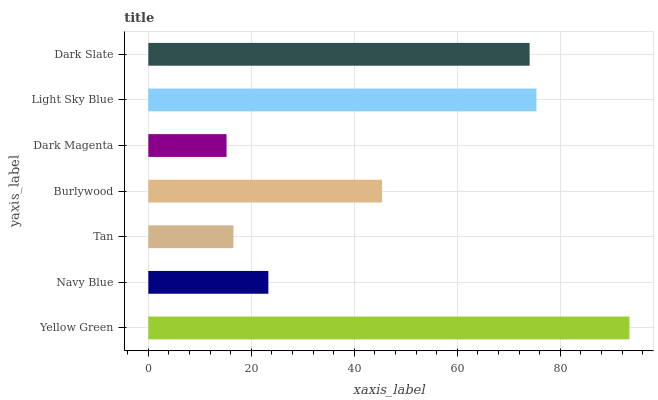Is Dark Magenta the minimum?
Answer yes or no. Yes. Is Yellow Green the maximum?
Answer yes or no. Yes. Is Navy Blue the minimum?
Answer yes or no. No. Is Navy Blue the maximum?
Answer yes or no. No. Is Yellow Green greater than Navy Blue?
Answer yes or no. Yes. Is Navy Blue less than Yellow Green?
Answer yes or no. Yes. Is Navy Blue greater than Yellow Green?
Answer yes or no. No. Is Yellow Green less than Navy Blue?
Answer yes or no. No. Is Burlywood the high median?
Answer yes or no. Yes. Is Burlywood the low median?
Answer yes or no. Yes. Is Light Sky Blue the high median?
Answer yes or no. No. Is Dark Slate the low median?
Answer yes or no. No. 